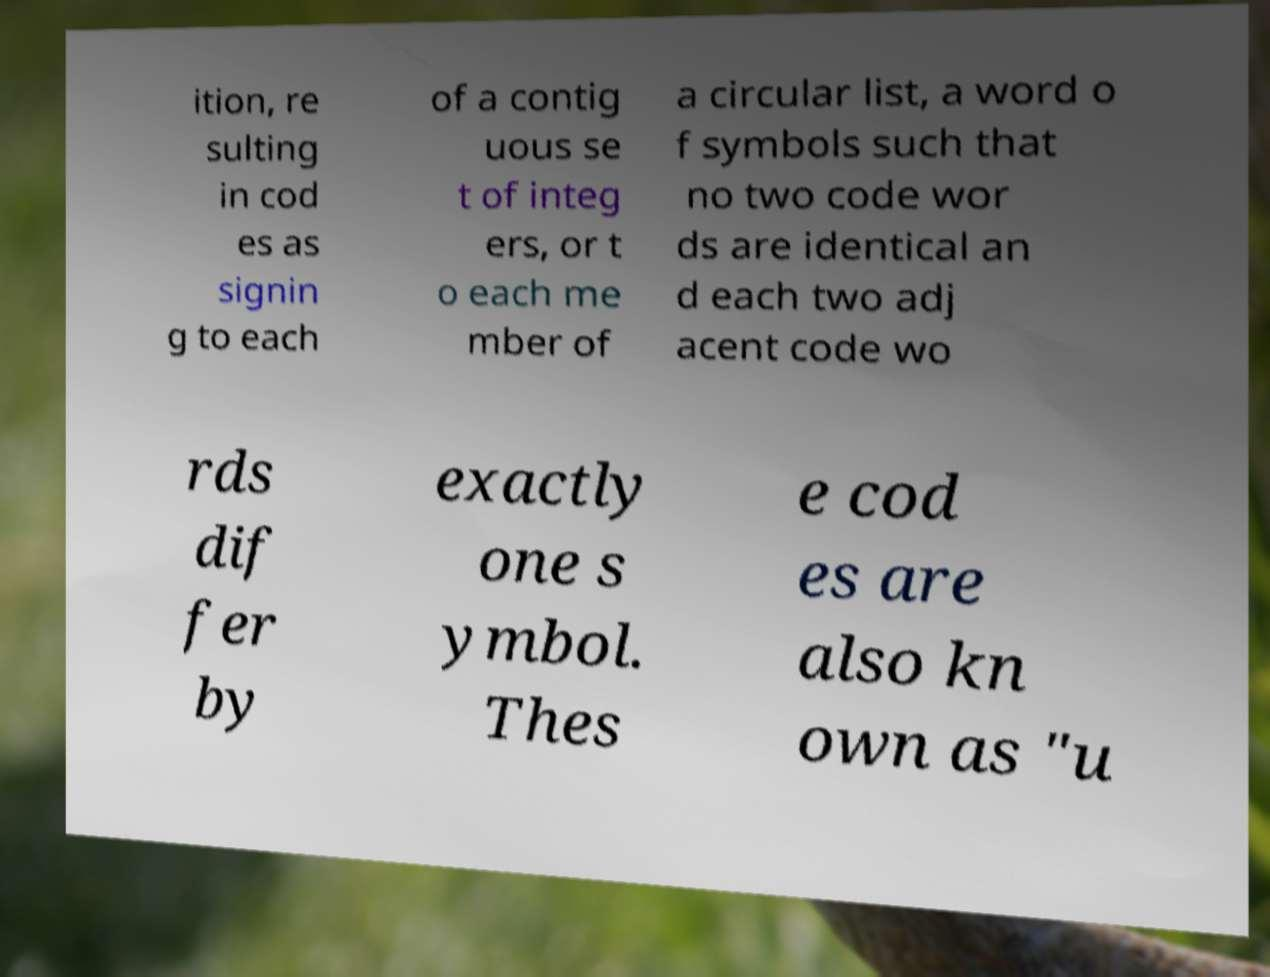What messages or text are displayed in this image? I need them in a readable, typed format. ition, re sulting in cod es as signin g to each of a contig uous se t of integ ers, or t o each me mber of a circular list, a word o f symbols such that no two code wor ds are identical an d each two adj acent code wo rds dif fer by exactly one s ymbol. Thes e cod es are also kn own as "u 